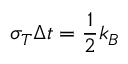<formula> <loc_0><loc_0><loc_500><loc_500>\sigma _ { T } \Delta t = \frac { 1 } { 2 } k _ { B }</formula> 